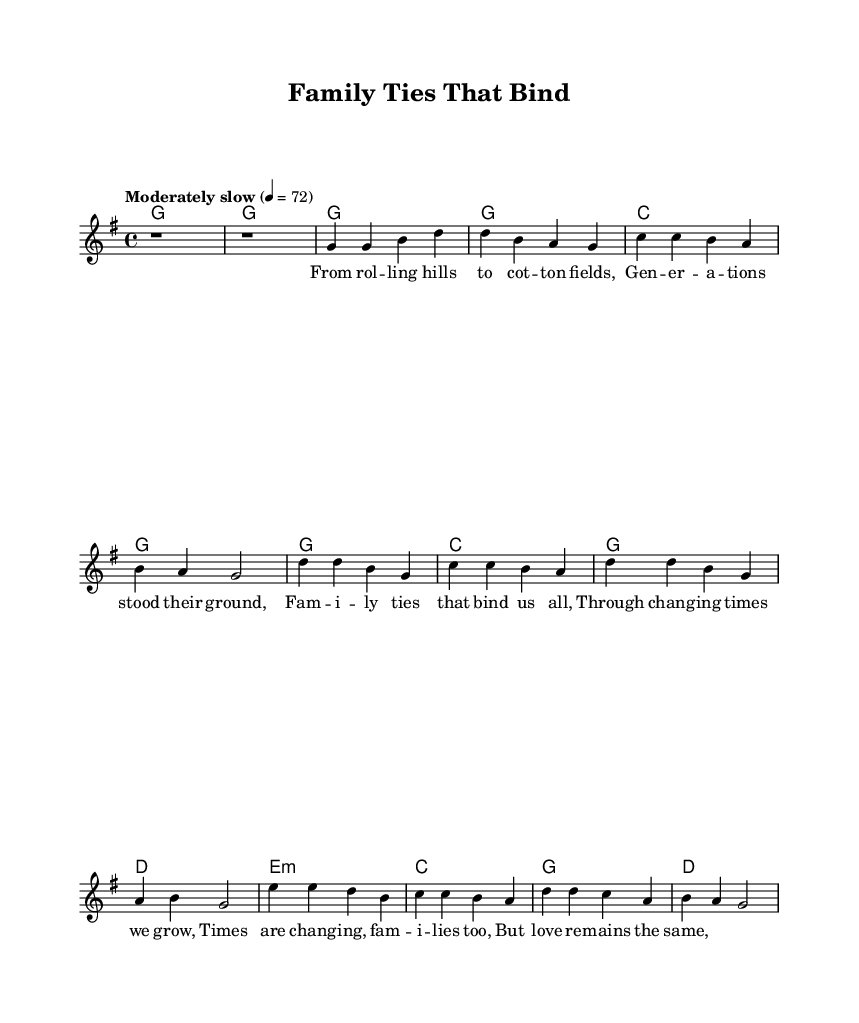What is the key signature of this music? The key signature can be found at the beginning of the staff, which indicates G major as it has one sharp (F#) in its scale.
Answer: G major What is the time signature of the piece? The time signature is displayed at the beginning of the music as 4/4, which means there are four beats in each measure.
Answer: 4/4 What is the tempo marking for the piece? The tempo can be found in the score, which indicates "Moderately slow" with a metronome mark of 72 beats per minute.
Answer: Moderately slow 72 How many measures are there in the verse section? By counting the music notation in the verse section, there are four measures shown that consist of the melody and lyrics.
Answer: Four What is the primary theme depicted in the lyrics? The lyrics reflect on family ties and the changes that families go through over time, which is conveyed through the phrases in the verse and chorus sections.
Answer: Family ties What chord follows the first line of the verse? The chord shown in the first measure where the lyrics start is G major, which accompanies the melody when it begins that line.
Answer: G What does the bridge section reveal about family dynamics? The bridge discusses the changing times and how families evolve, while highlighting that love remains constant, emphasizing the stability within familial relationships despite changes.
Answer: Love remains the same 